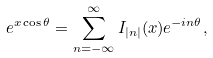<formula> <loc_0><loc_0><loc_500><loc_500>e ^ { x \cos \theta } = \sum _ { n = - \infty } ^ { \infty } I _ { | n | } ( x ) e ^ { - i n \theta } ,</formula> 